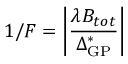Convert formula to latex. <formula><loc_0><loc_0><loc_500><loc_500>1 / F = \left | \frac { \lambda B _ { t o t } } { \Delta _ { G P } ^ { * } } \right |</formula> 